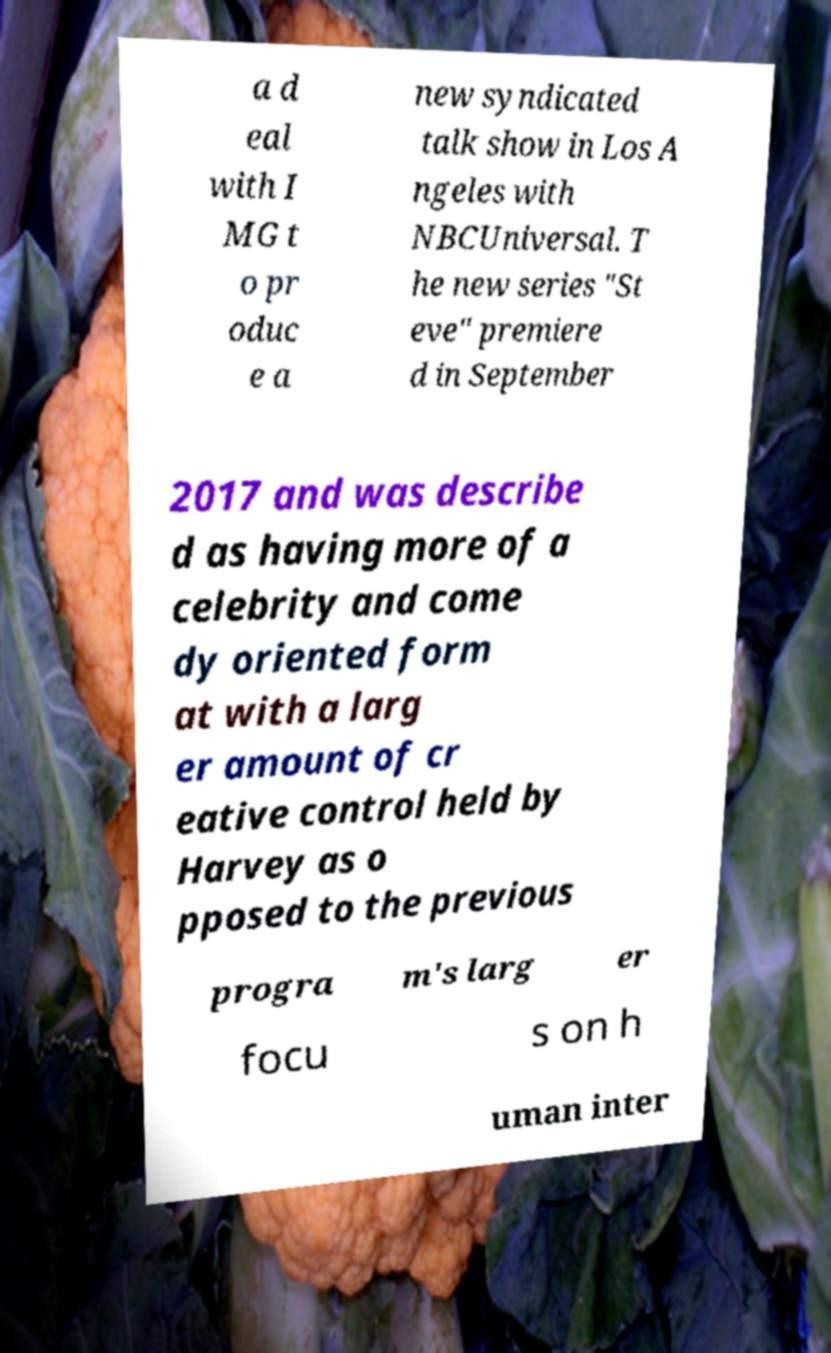For documentation purposes, I need the text within this image transcribed. Could you provide that? a d eal with I MG t o pr oduc e a new syndicated talk show in Los A ngeles with NBCUniversal. T he new series "St eve" premiere d in September 2017 and was describe d as having more of a celebrity and come dy oriented form at with a larg er amount of cr eative control held by Harvey as o pposed to the previous progra m's larg er focu s on h uman inter 